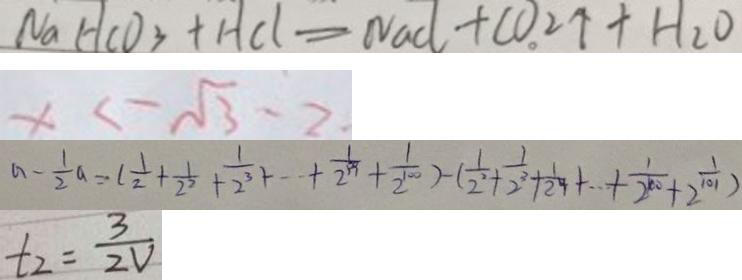<formula> <loc_0><loc_0><loc_500><loc_500>N a H C O _ { 3 } + H C l = N a C l + C O _ { 2 } \uparrow + H _ { 2 } O 
 x < \sqrt { 3 } - 2 . 
 a - \frac { 1 } { 2 } a = ( \frac { 1 } { 2 } + \frac { 1 } { 2 ^ { 2 } } + \frac { 1 } { 2 ^ { 3 } } + \cdots + \frac { 1 } { 2 ^ { 9 9 } } + \frac { 1 } { 2 ^ { 1 0 0 } } ) - ( \frac { 1 } { 2 ^ { 2 } } + \frac { 1 } { 2 ^ { 3 } } + \frac { 1 } { 2 ^ { 4 } } + \cdots + \frac { 1 } { 2 ^ { 1 0 0 } } + \frac { 1 } { 2 ^ { 1 0 1 } } ) 
 t _ { 2 } = \frac { 3 } { 2 V }</formula> 